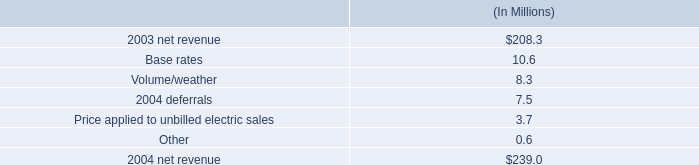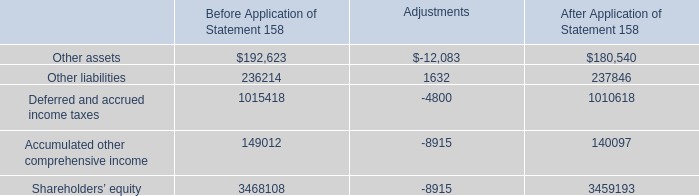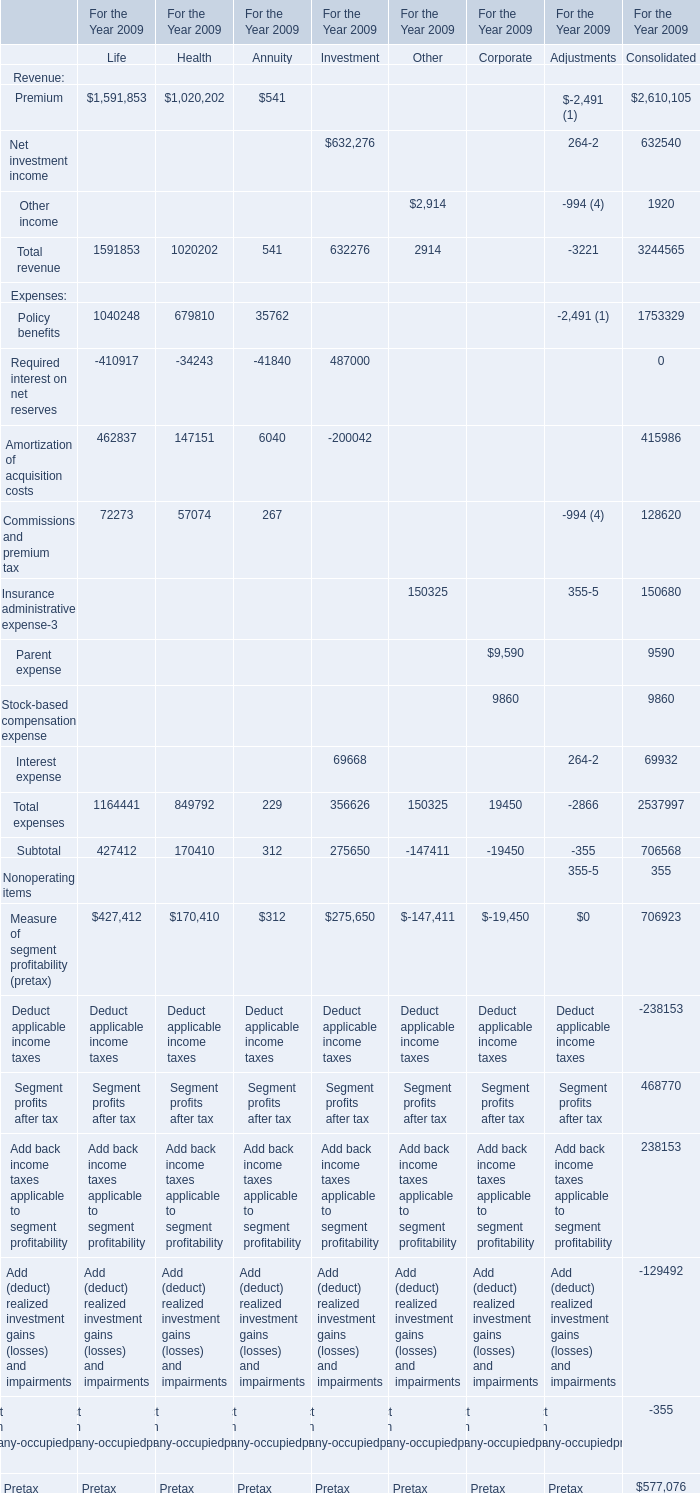What is the average amount of Accumulated other comprehensive income of After Application of Statement 158, and Premium of For the Year 2009 Life ? 
Computations: ((140097.0 + 1591853.0) / 2)
Answer: 865975.0. 